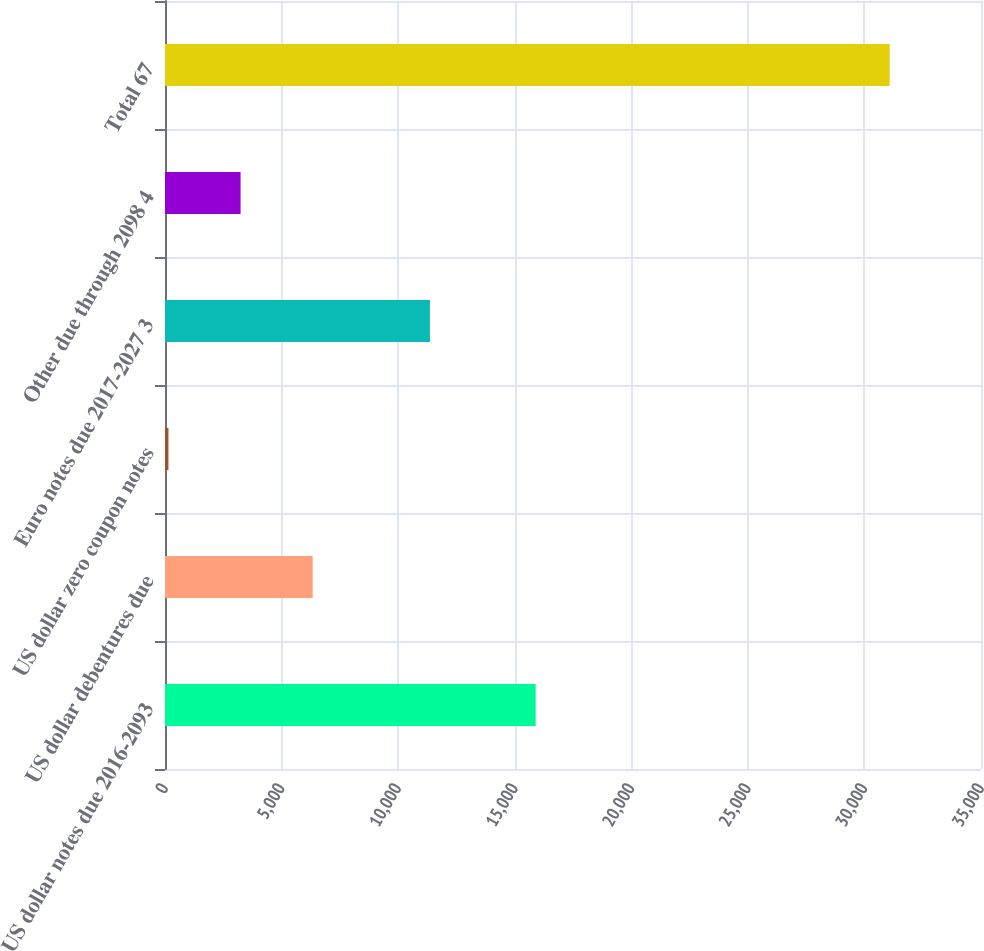Convert chart. <chart><loc_0><loc_0><loc_500><loc_500><bar_chart><fcel>US dollar notes due 2016-2093<fcel>US dollar debentures due<fcel>US dollar zero coupon notes<fcel>Euro notes due 2017-2027 3<fcel>Other due through 2098 4<fcel>Total 67<nl><fcel>15899<fcel>6335.2<fcel>148<fcel>11364<fcel>3241.6<fcel>31084<nl></chart> 